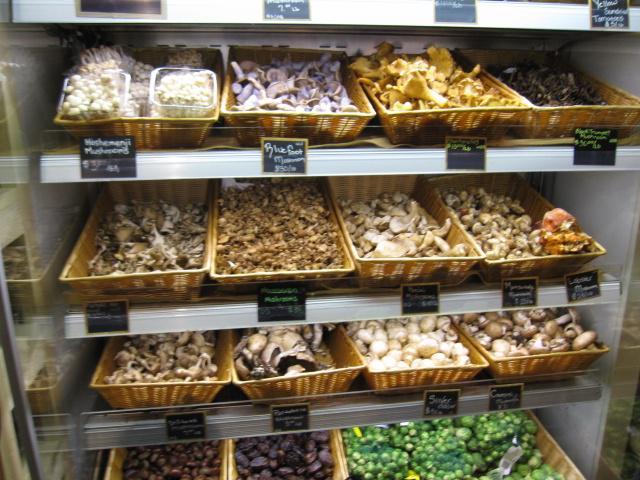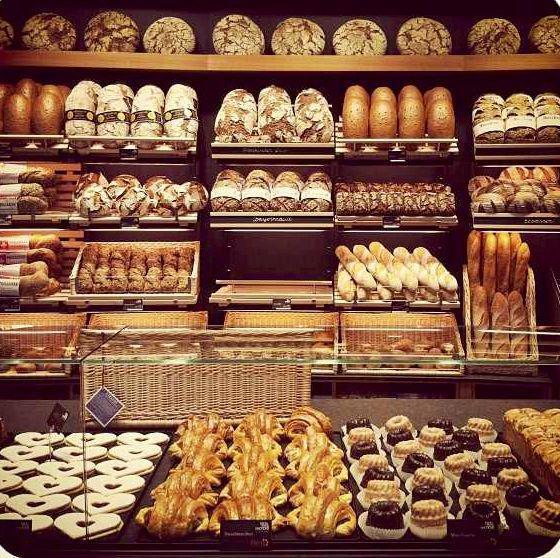The first image is the image on the left, the second image is the image on the right. For the images displayed, is the sentence "The labels are handwritten in one of the images." factually correct? Answer yes or no. Yes. 